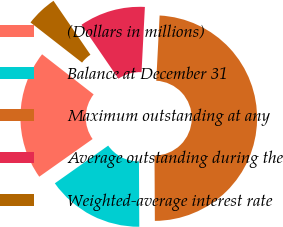Convert chart to OTSL. <chart><loc_0><loc_0><loc_500><loc_500><pie_chart><fcel>(Dollars in millions)<fcel>Balance at December 31<fcel>Maximum outstanding at any<fcel>Average outstanding during the<fcel>Weighted-average interest rate<nl><fcel>20.32%<fcel>15.29%<fcel>49.1%<fcel>10.38%<fcel>4.91%<nl></chart> 